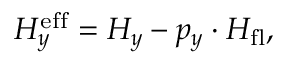<formula> <loc_0><loc_0><loc_500><loc_500>H _ { y } ^ { e f f } = H _ { y } - p _ { y } \cdot H _ { f l } ,</formula> 